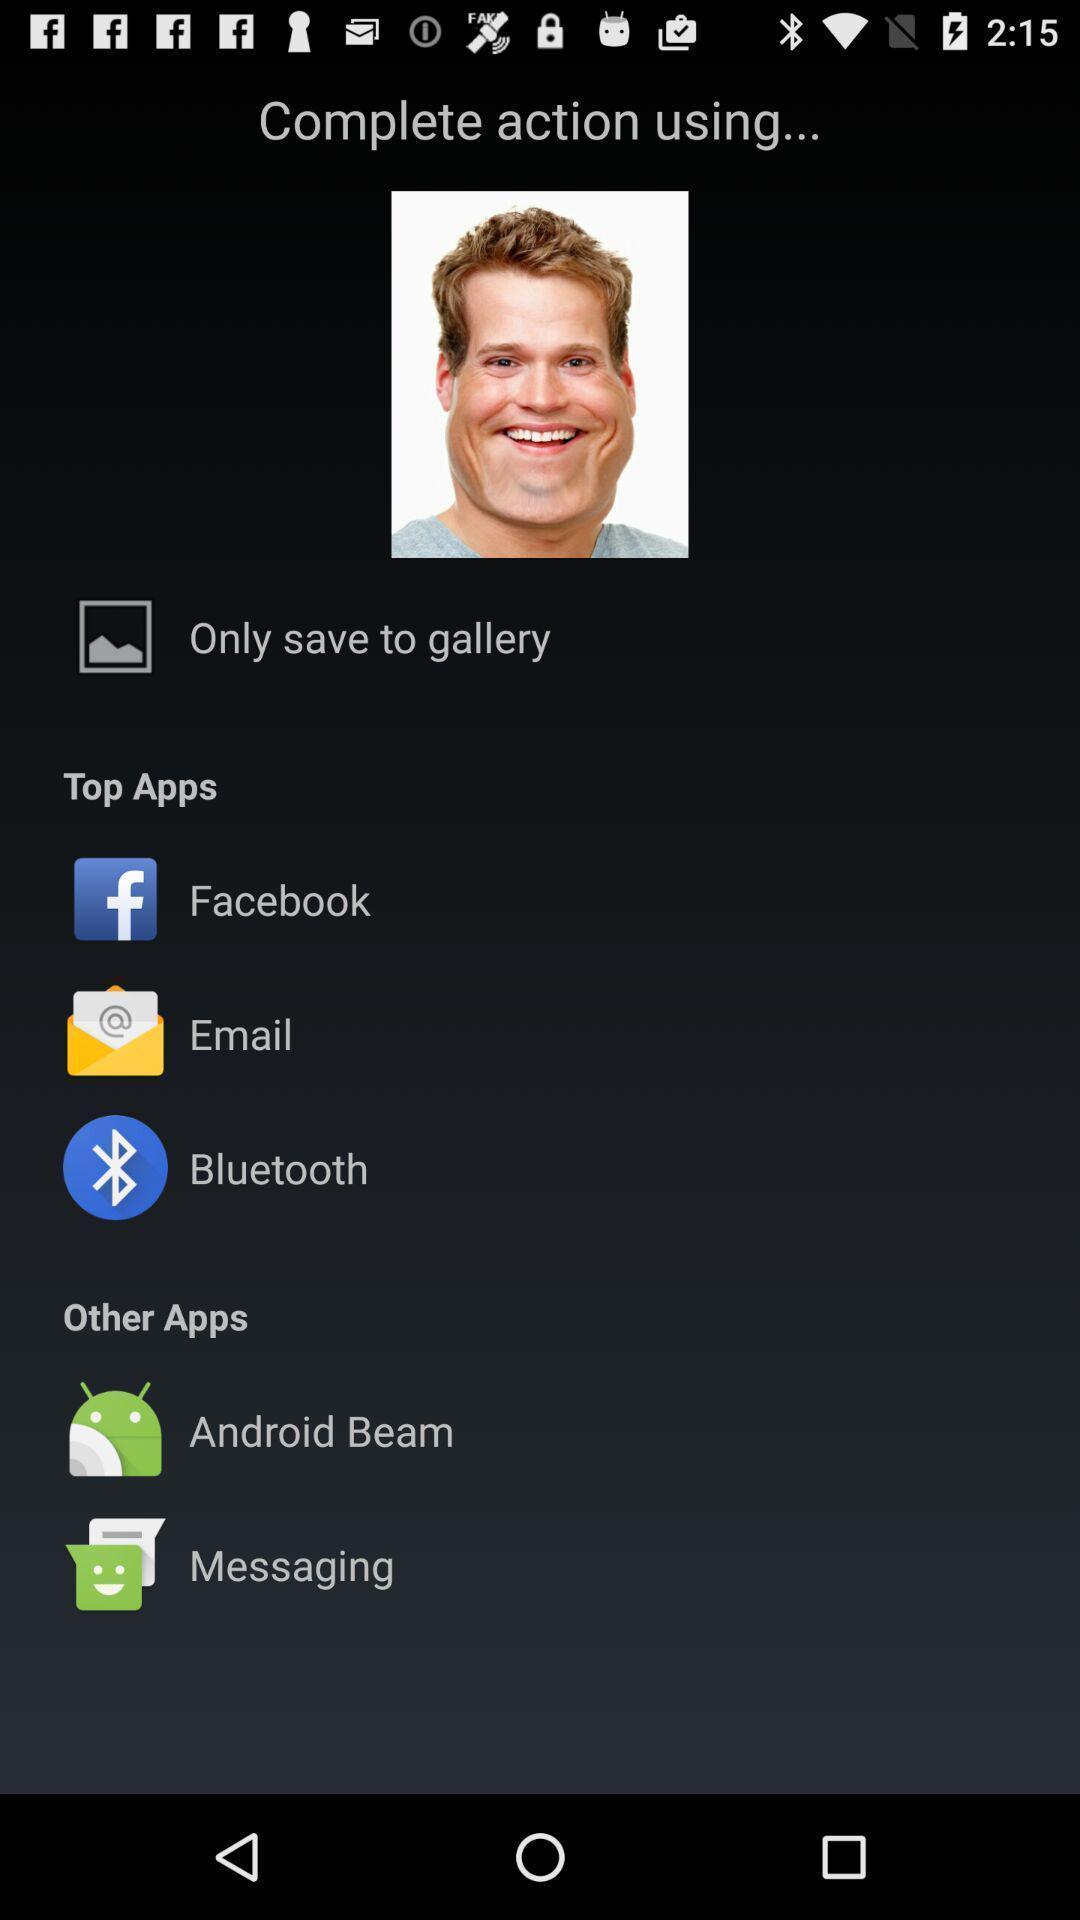Describe this image in words. Screen displaying user image and multiple application icons and names. 